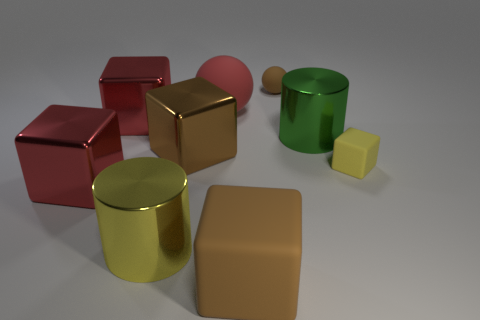There is a red matte object that is in front of the brown object that is behind the metallic thing to the right of the red rubber ball; what shape is it?
Give a very brief answer. Sphere. There is a large green thing that is the same material as the large yellow cylinder; what shape is it?
Keep it short and to the point. Cylinder. The green object has what size?
Provide a short and direct response. Large. Is the size of the brown rubber sphere the same as the yellow metallic thing?
Your answer should be very brief. No. How many objects are either matte objects in front of the green cylinder or cylinders that are to the right of the large rubber ball?
Ensure brevity in your answer.  3. There is a big cylinder on the left side of the tiny rubber object that is behind the yellow cube; what number of big metal cylinders are to the right of it?
Your response must be concise. 1. What size is the yellow object to the left of the green metallic cylinder?
Make the answer very short. Large. What number of red metal things have the same size as the green cylinder?
Offer a terse response. 2. There is a yellow matte object; is its size the same as the metallic thing to the right of the tiny sphere?
Your response must be concise. No. What number of things are either big brown balls or large yellow cylinders?
Offer a terse response. 1. 